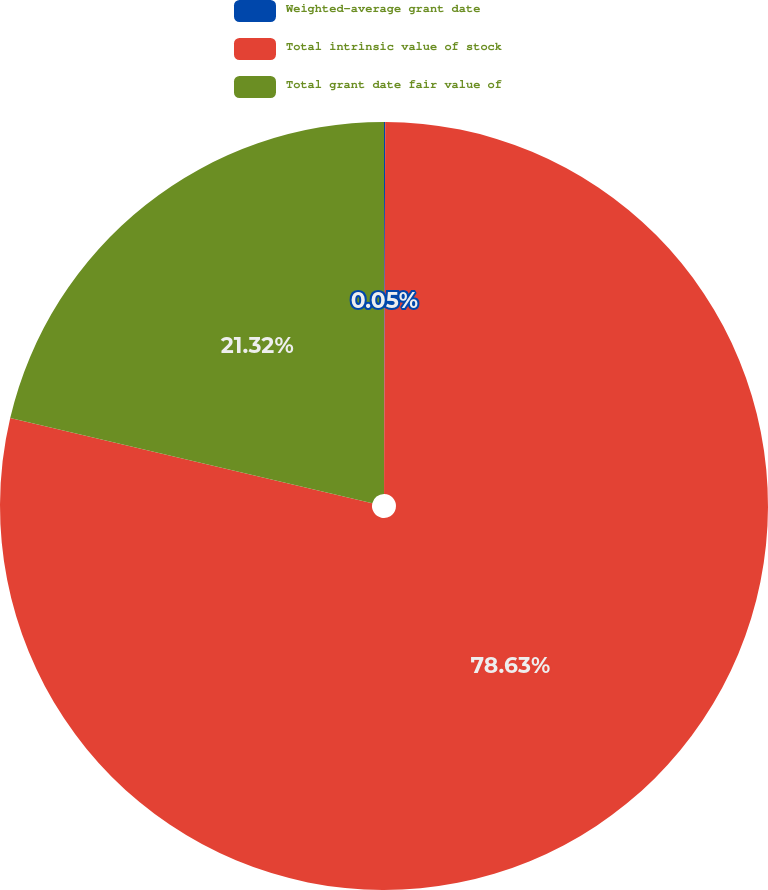Convert chart. <chart><loc_0><loc_0><loc_500><loc_500><pie_chart><fcel>Weighted-average grant date<fcel>Total intrinsic value of stock<fcel>Total grant date fair value of<nl><fcel>0.05%<fcel>78.63%<fcel>21.32%<nl></chart> 